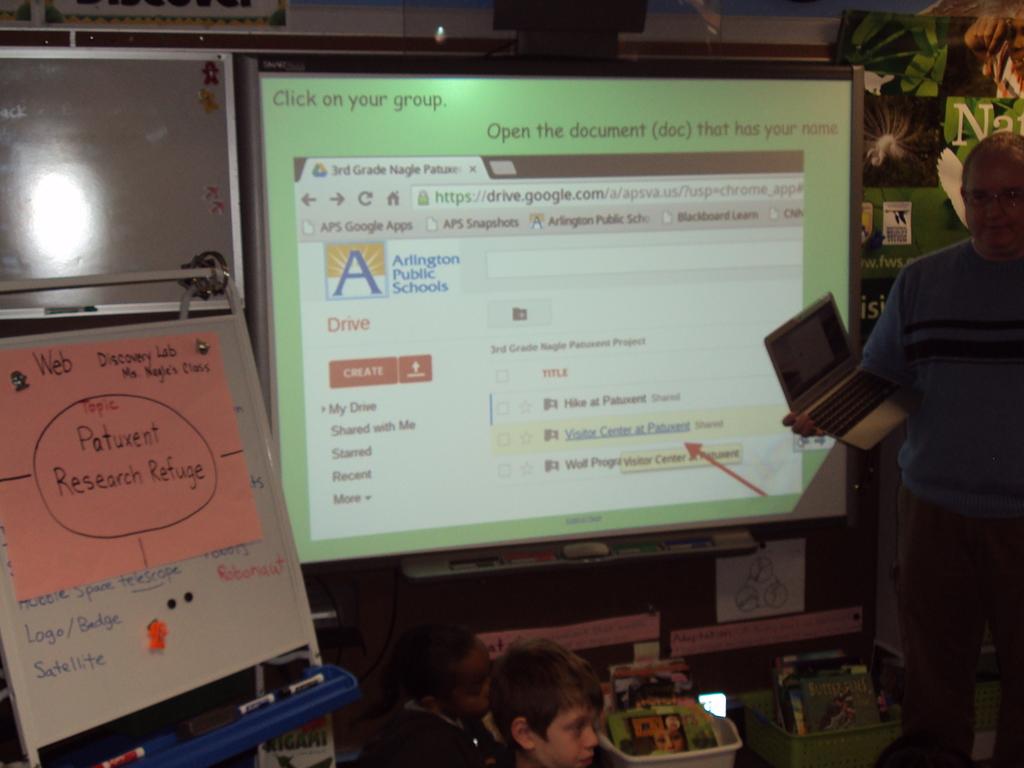What is the name of the school on the powerpoint?
Offer a very short reply. Arlington public schools. What type of research refuge is shown on the pink sheet of paper?
Provide a short and direct response. Patuxent. 